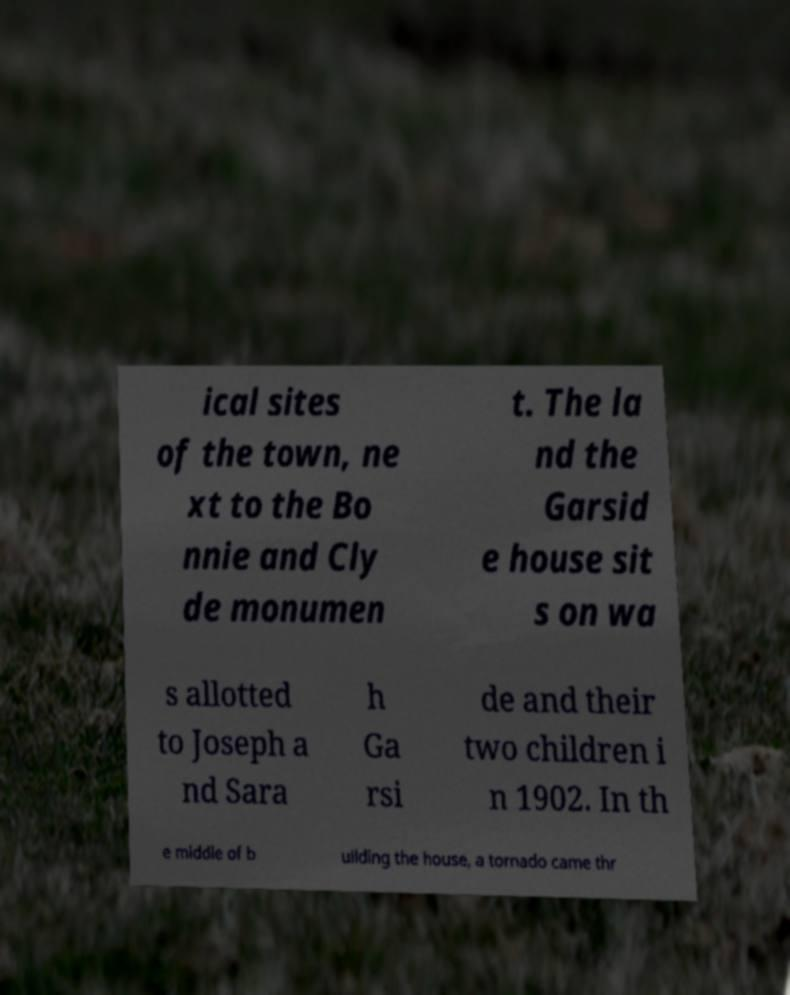Please read and relay the text visible in this image. What does it say? ical sites of the town, ne xt to the Bo nnie and Cly de monumen t. The la nd the Garsid e house sit s on wa s allotted to Joseph a nd Sara h Ga rsi de and their two children i n 1902. In th e middle of b uilding the house, a tornado came thr 